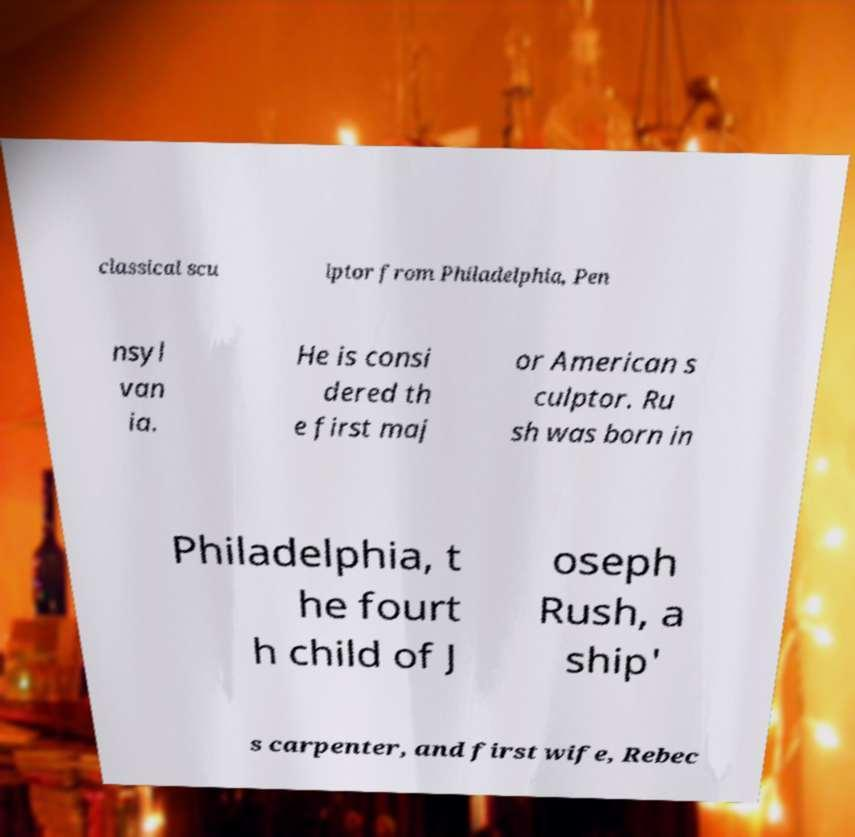Could you extract and type out the text from this image? classical scu lptor from Philadelphia, Pen nsyl van ia. He is consi dered th e first maj or American s culptor. Ru sh was born in Philadelphia, t he fourt h child of J oseph Rush, a ship' s carpenter, and first wife, Rebec 